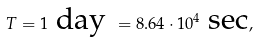Convert formula to latex. <formula><loc_0><loc_0><loc_500><loc_500>T = 1 \text { day } = 8 . 6 4 \cdot 1 0 ^ { 4 } \text { sec} ,</formula> 